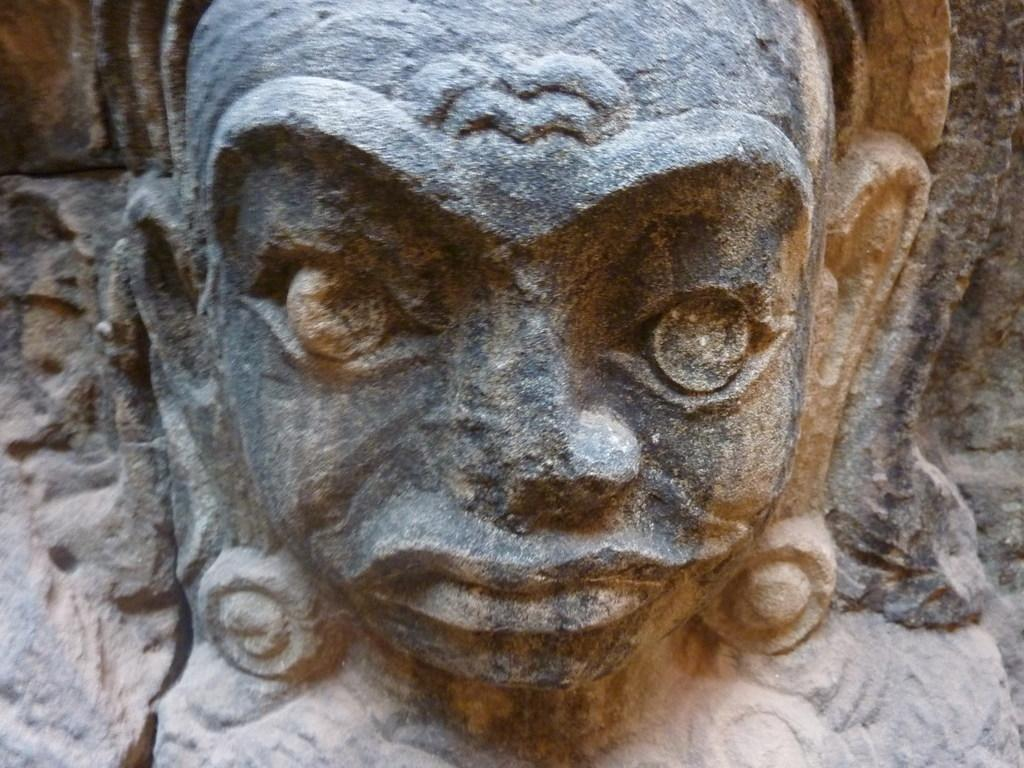What is the main subject of the image? The main subject of the image is a sculpture. Where is the sculpture located in the image? The sculpture is attached to a wall. What rule is being enforced by the sculpture in the image? There is no rule being enforced by the sculpture in the image, as it is a static object and not a person or authority figure. 